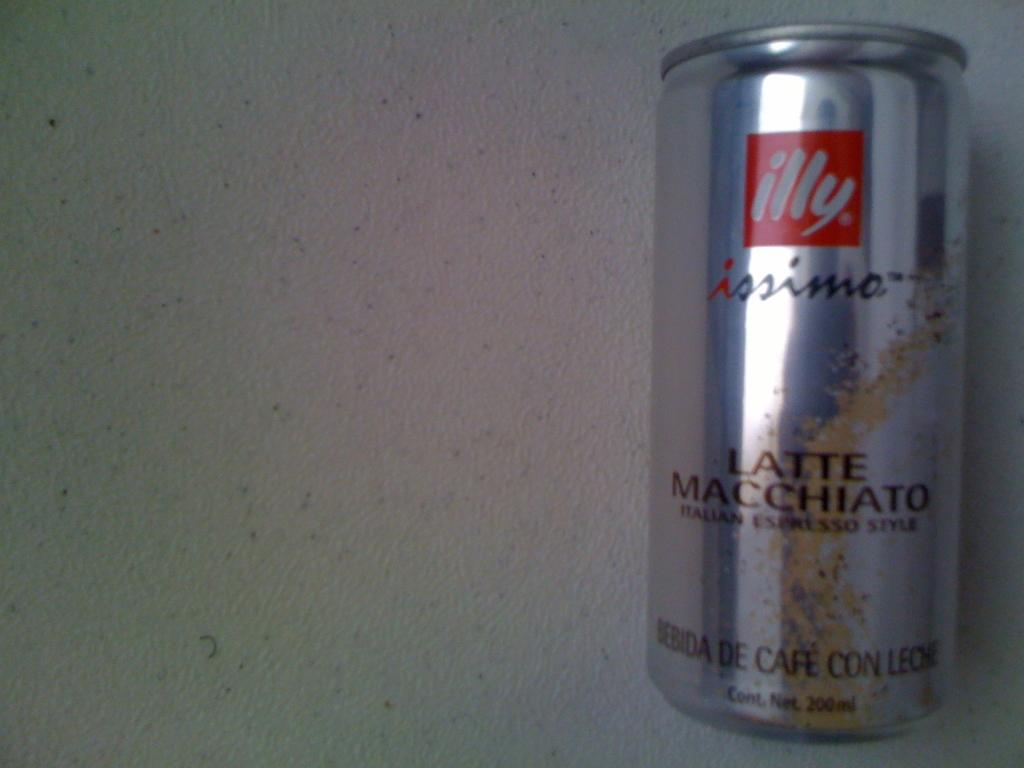<image>
Render a clear and concise summary of the photo. A can of illy brand latte macchiato sits on a white table. 